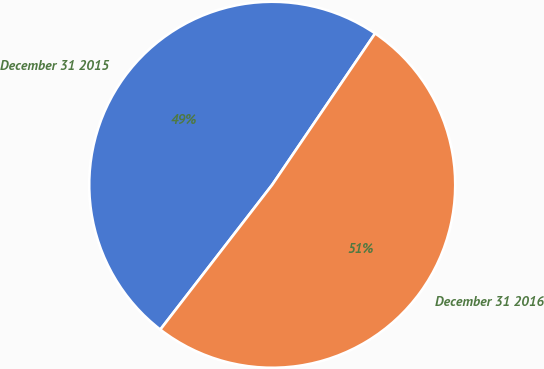Convert chart. <chart><loc_0><loc_0><loc_500><loc_500><pie_chart><fcel>December 31 2015<fcel>December 31 2016<nl><fcel>49.03%<fcel>50.97%<nl></chart> 